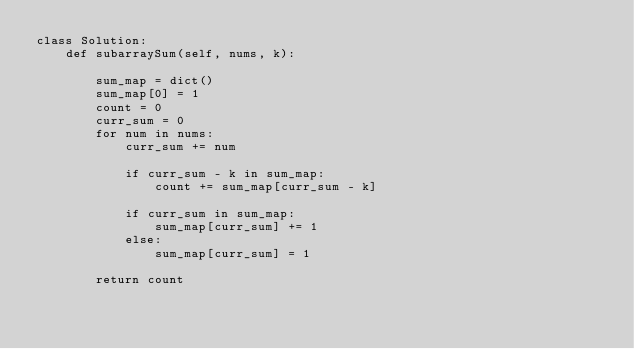<code> <loc_0><loc_0><loc_500><loc_500><_Python_>class Solution:
    def subarraySum(self, nums, k):

        sum_map = dict()
        sum_map[0] = 1
        count = 0
        curr_sum = 0
        for num in nums:
            curr_sum += num

            if curr_sum - k in sum_map:
                count += sum_map[curr_sum - k]

            if curr_sum in sum_map:
                sum_map[curr_sum] += 1
            else:
                sum_map[curr_sum] = 1

        return count
</code> 